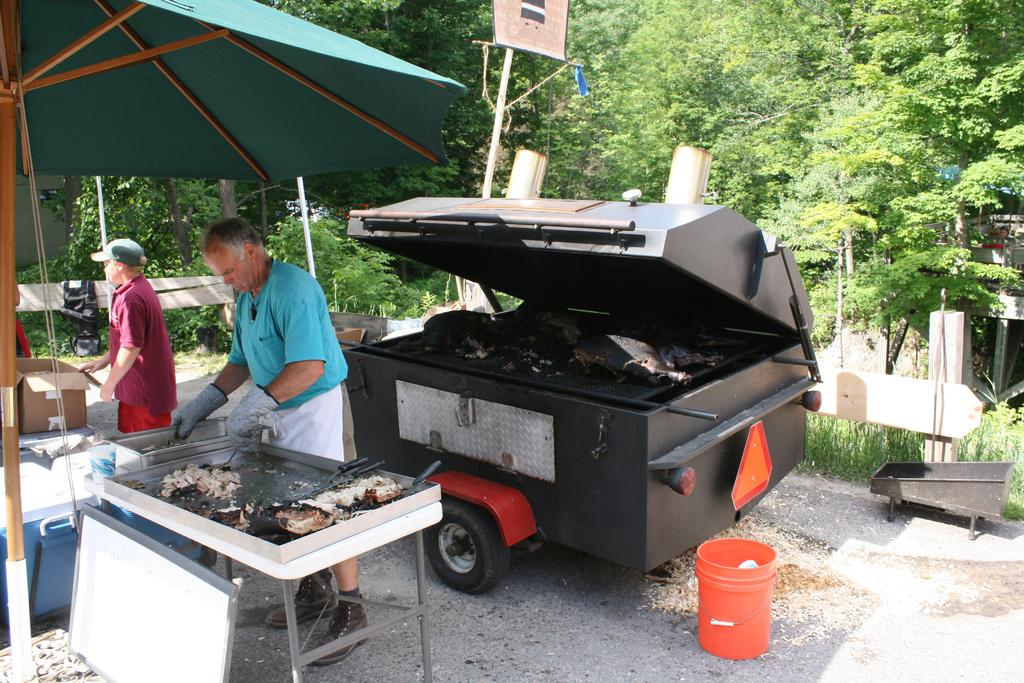What is the man in the image doing? The man is standing and trying to cook something. Can you describe the other person in the image? The other person is on the left side of the image and is wearing a cap. What object can be seen in the image that provides shelter from the rain? There is an umbrella in the image. What type of natural vegetation is visible in the image? There are trees in the image. What type of soap is being used to clean the sock in the image? There is no soap or sock present in the image. 